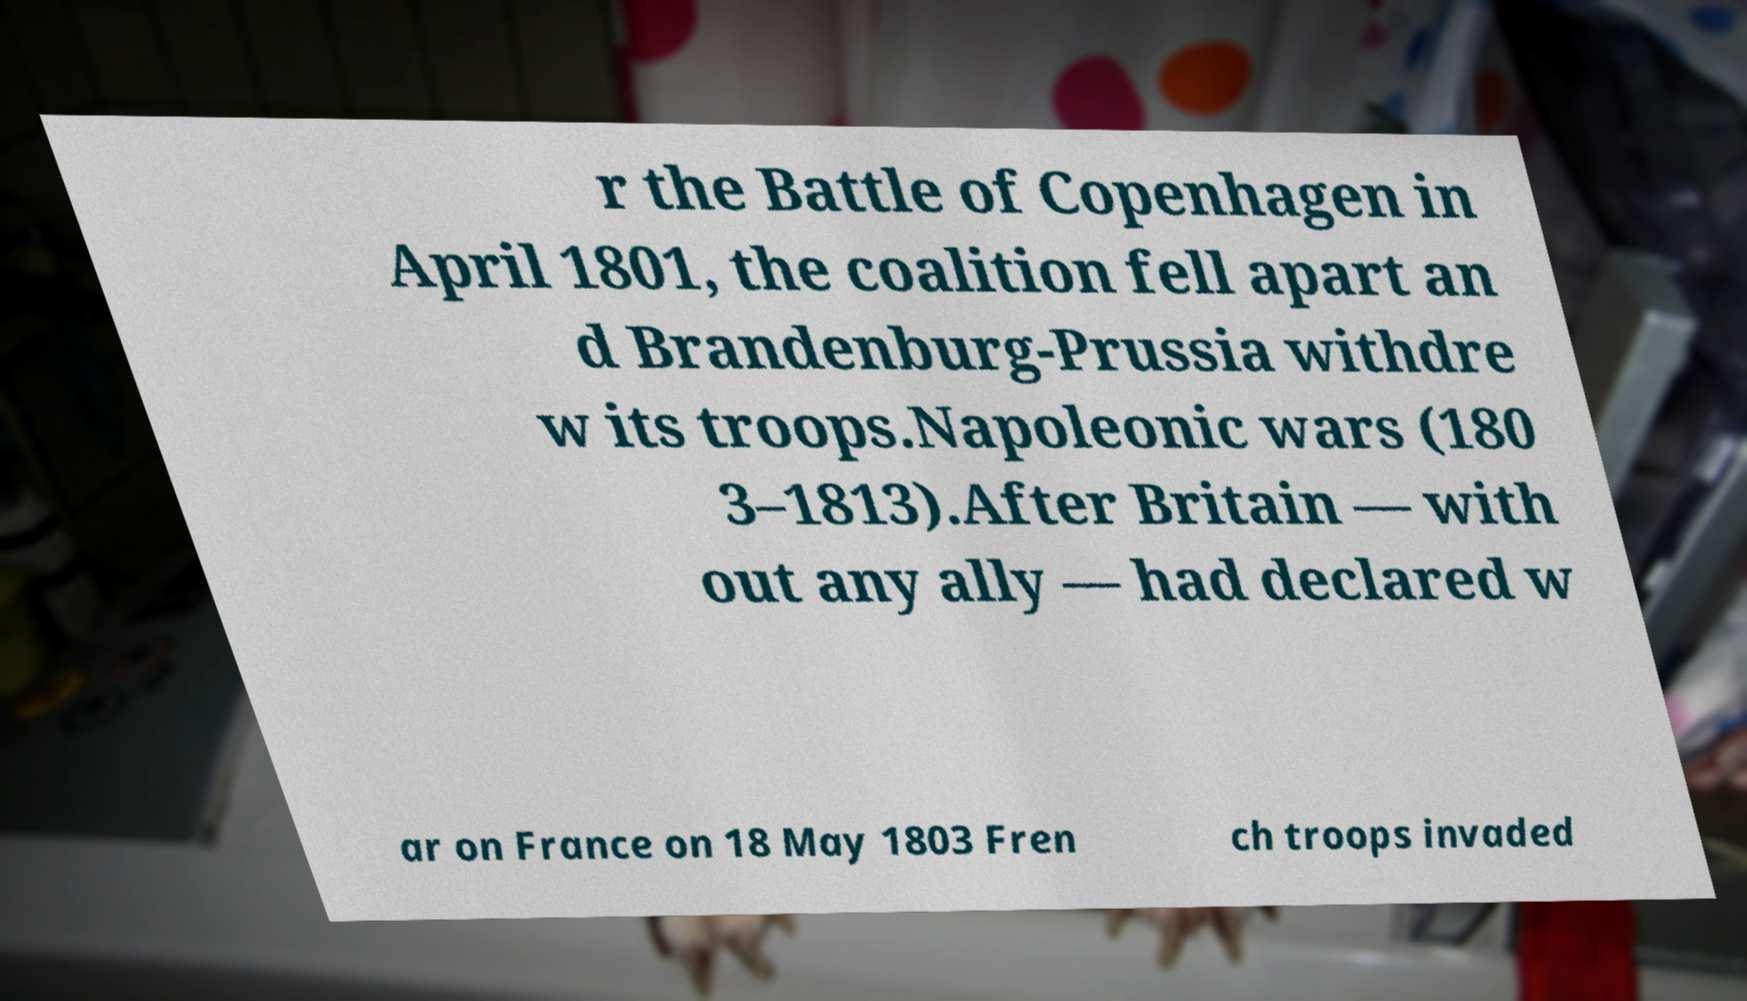Can you accurately transcribe the text from the provided image for me? r the Battle of Copenhagen in April 1801, the coalition fell apart an d Brandenburg-Prussia withdre w its troops.Napoleonic wars (180 3–1813).After Britain — with out any ally — had declared w ar on France on 18 May 1803 Fren ch troops invaded 